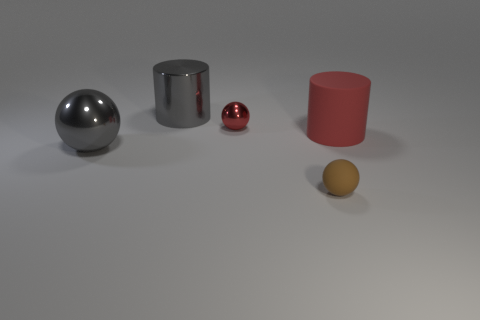Subtract all yellow balls. Subtract all red cylinders. How many balls are left? 3 Add 4 brown matte cylinders. How many objects exist? 9 Subtract all balls. How many objects are left? 2 Add 2 red matte things. How many red matte things are left? 3 Add 1 tiny purple metallic cubes. How many tiny purple metallic cubes exist? 1 Subtract 0 cyan cubes. How many objects are left? 5 Subtract all small brown rubber things. Subtract all cylinders. How many objects are left? 2 